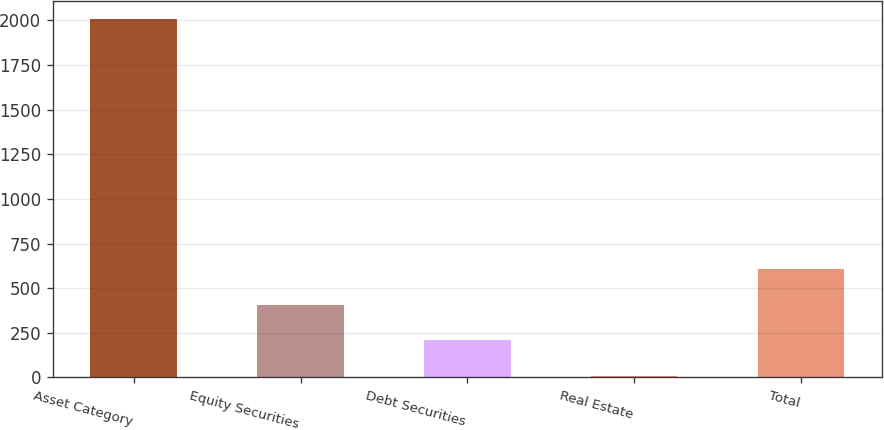Convert chart. <chart><loc_0><loc_0><loc_500><loc_500><bar_chart><fcel>Asset Category<fcel>Equity Securities<fcel>Debt Securities<fcel>Real Estate<fcel>Total<nl><fcel>2007<fcel>407<fcel>207<fcel>7<fcel>607<nl></chart> 